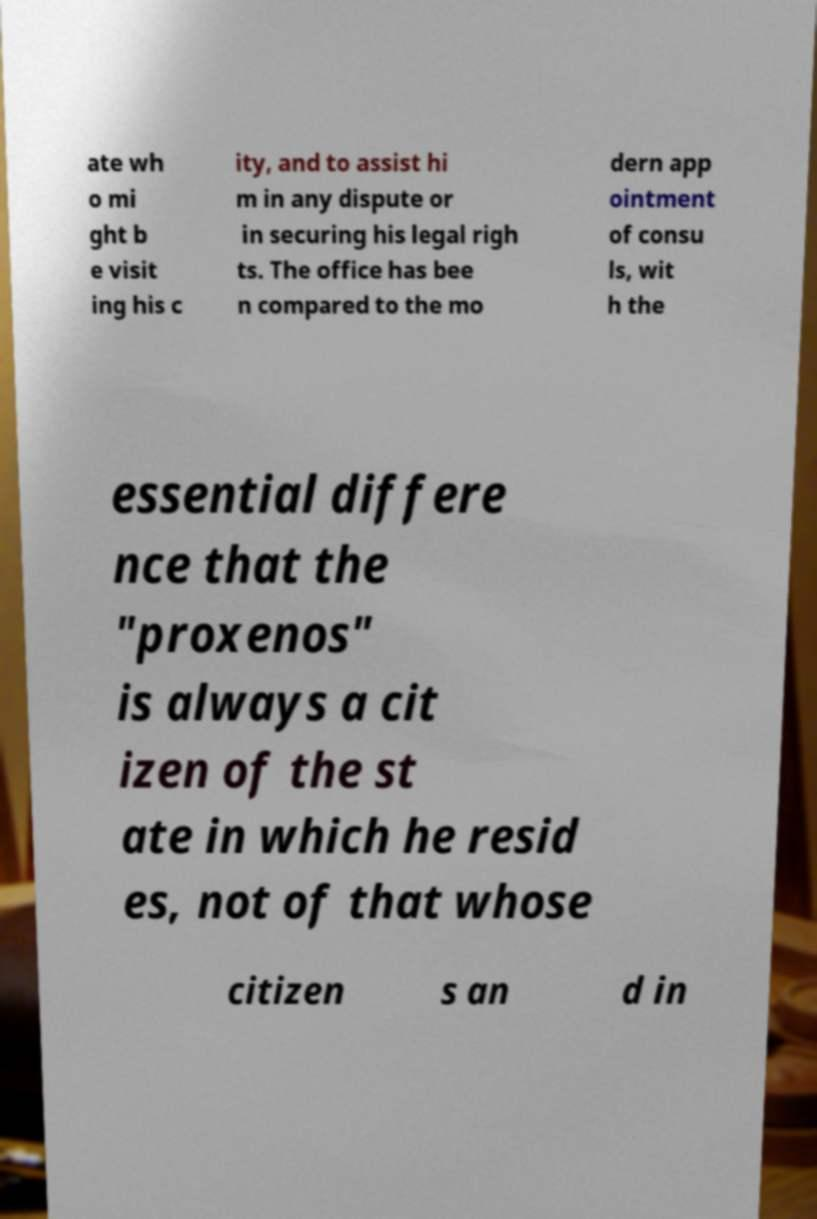Please read and relay the text visible in this image. What does it say? ate wh o mi ght b e visit ing his c ity, and to assist hi m in any dispute or in securing his legal righ ts. The office has bee n compared to the mo dern app ointment of consu ls, wit h the essential differe nce that the "proxenos" is always a cit izen of the st ate in which he resid es, not of that whose citizen s an d in 